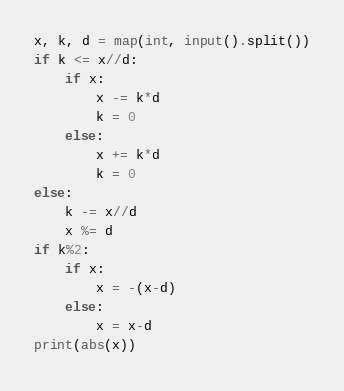Convert code to text. <code><loc_0><loc_0><loc_500><loc_500><_Python_>x, k, d = map(int, input().split())
if k <= x//d:
    if x:
        x -= k*d
        k = 0
    else:
        x += k*d
        k = 0
else:
    k -= x//d
    x %= d
if k%2:
    if x:
        x = -(x-d)
    else:
        x = x-d
print(abs(x))</code> 